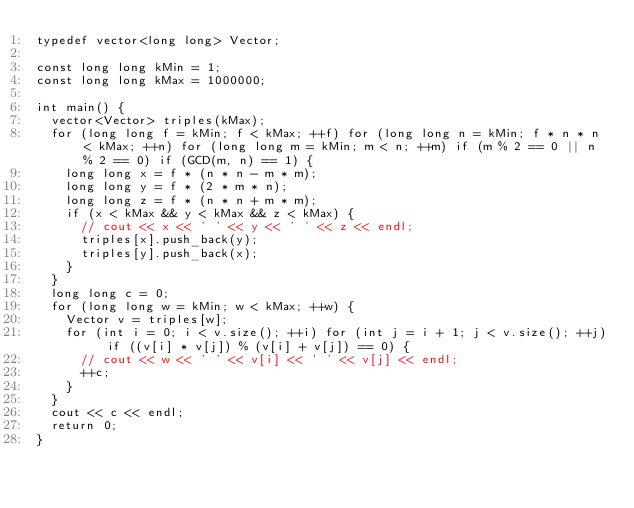Convert code to text. <code><loc_0><loc_0><loc_500><loc_500><_C++_>typedef vector<long long> Vector;

const long long kMin = 1;
const long long kMax = 1000000;

int main() {
  vector<Vector> triples(kMax);
  for (long long f = kMin; f < kMax; ++f) for (long long n = kMin; f * n * n < kMax; ++n) for (long long m = kMin; m < n; ++m) if (m % 2 == 0 || n % 2 == 0) if (GCD(m, n) == 1) {
    long long x = f * (n * n - m * m);
    long long y = f * (2 * m * n);
    long long z = f * (n * n + m * m);
    if (x < kMax && y < kMax && z < kMax) {
      // cout << x << ' ' << y << ' ' << z << endl;
      triples[x].push_back(y);
      triples[y].push_back(x);
    }
  }
  long long c = 0;
  for (long long w = kMin; w < kMax; ++w) {
    Vector v = triples[w];
    for (int i = 0; i < v.size(); ++i) for (int j = i + 1; j < v.size(); ++j) if ((v[i] * v[j]) % (v[i] + v[j]) == 0) {
      // cout << w << ' ' << v[i] << ' ' << v[j] << endl;
      ++c;
    }
  }
  cout << c << endl;
  return 0;
}</code> 